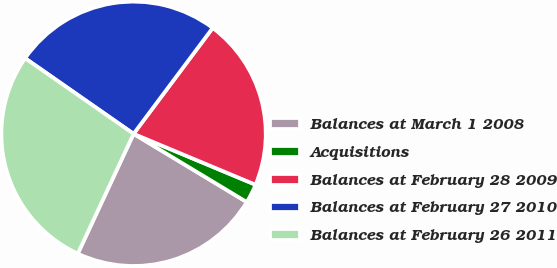Convert chart. <chart><loc_0><loc_0><loc_500><loc_500><pie_chart><fcel>Balances at March 1 2008<fcel>Acquisitions<fcel>Balances at February 28 2009<fcel>Balances at February 27 2010<fcel>Balances at February 26 2011<nl><fcel>23.3%<fcel>2.34%<fcel>21.08%<fcel>25.53%<fcel>27.75%<nl></chart> 